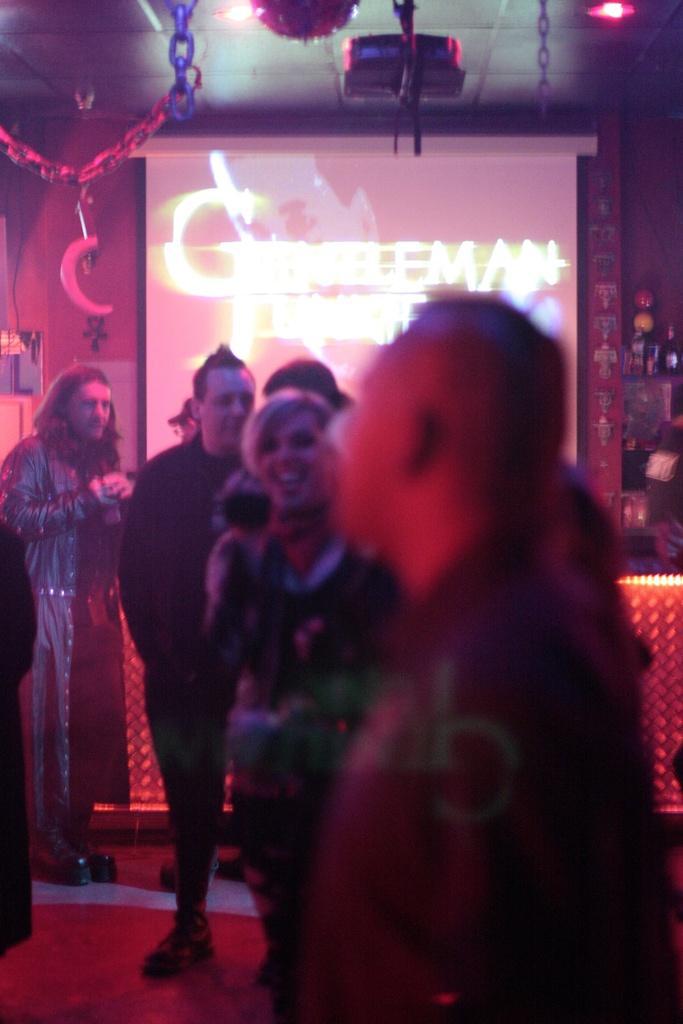Can you describe this image briefly? This picture is clicked inside. In the foreground we can see the group of people standing on the ground. In the background there is a projector screen on which we can see the text and there are some objects in the background. At the top there is a roof, ceiling lights, projector and some decoration items hanging on the roof. 